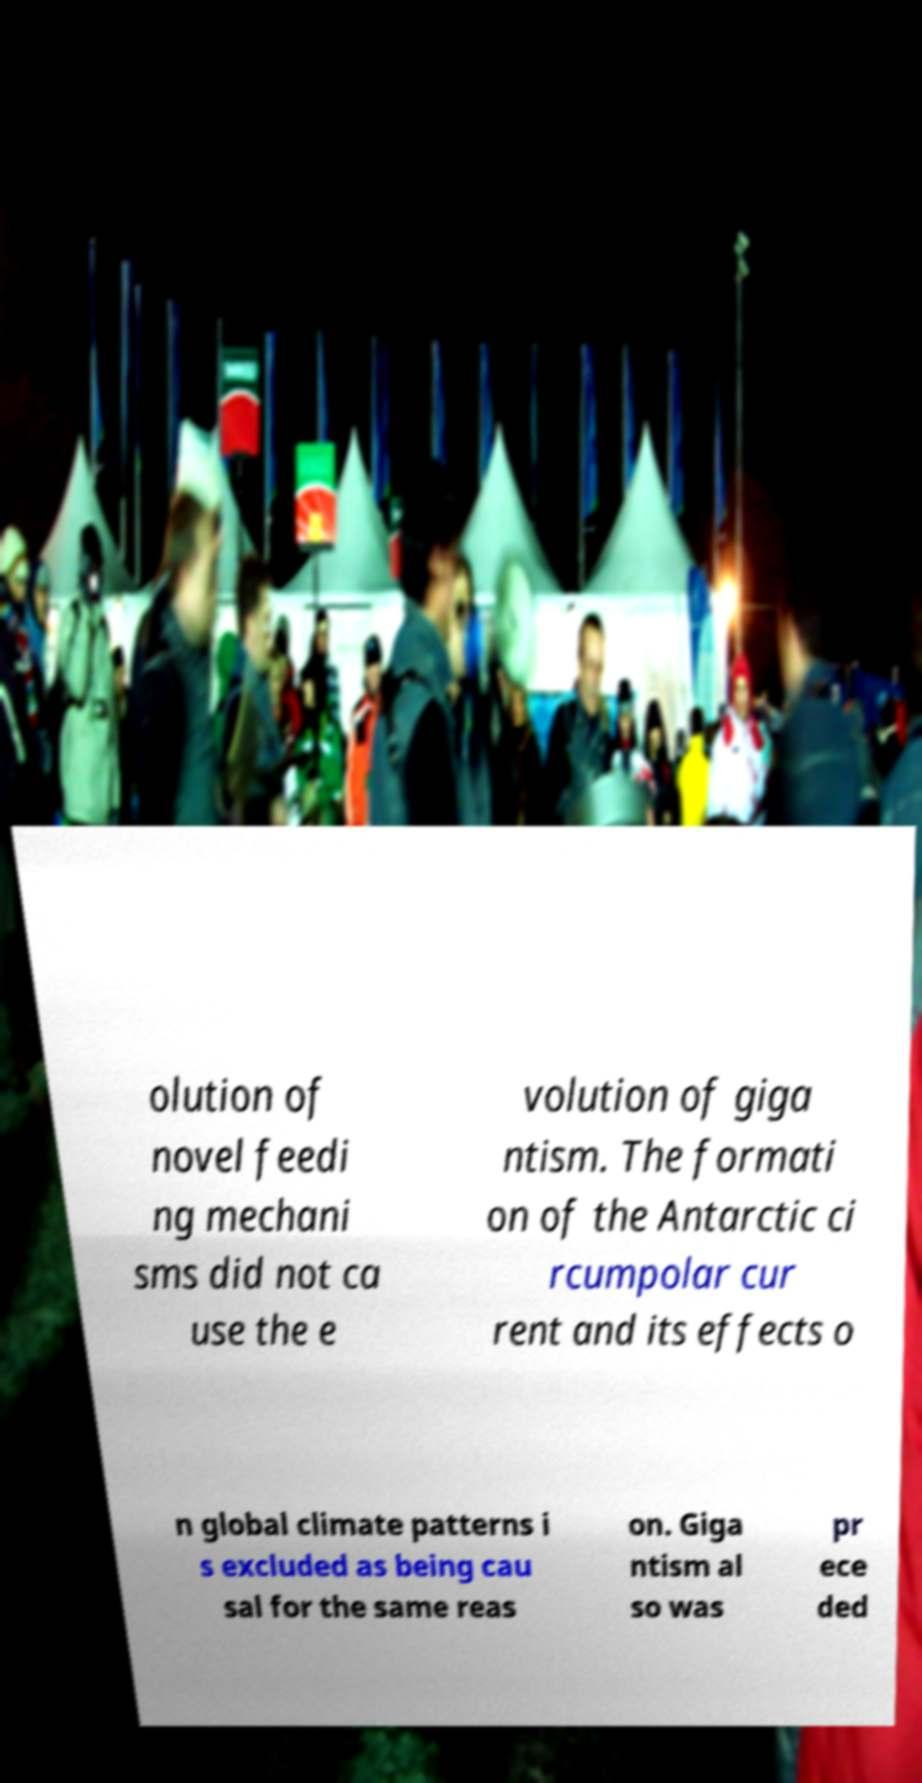Could you assist in decoding the text presented in this image and type it out clearly? olution of novel feedi ng mechani sms did not ca use the e volution of giga ntism. The formati on of the Antarctic ci rcumpolar cur rent and its effects o n global climate patterns i s excluded as being cau sal for the same reas on. Giga ntism al so was pr ece ded 